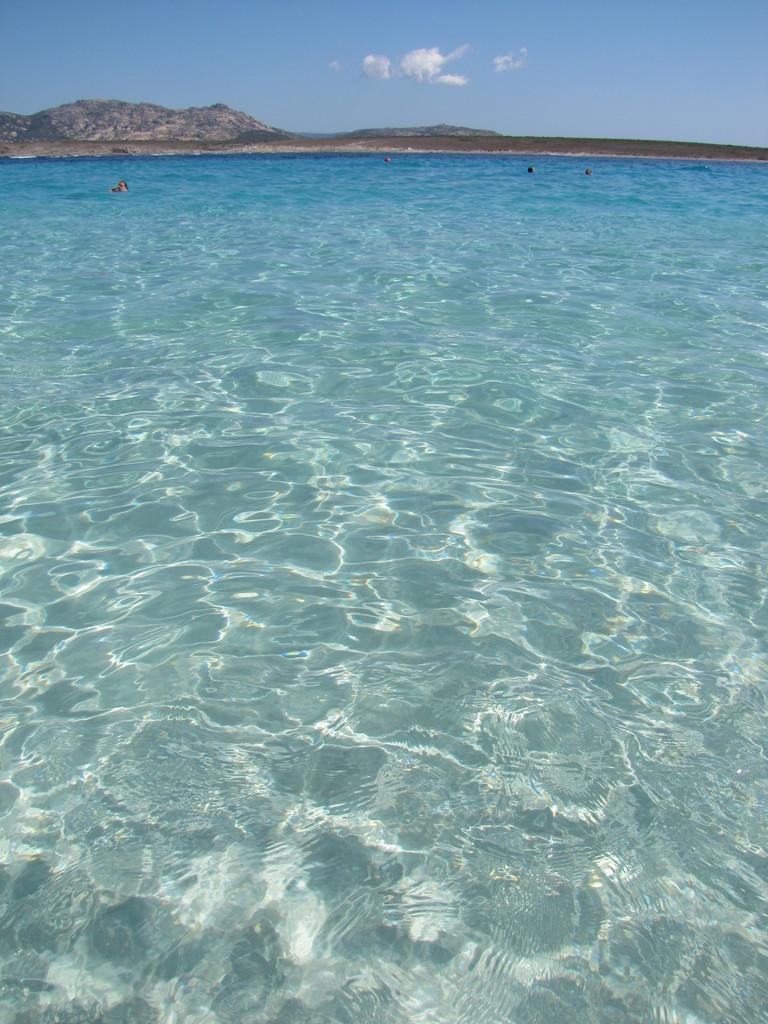In one or two sentences, can you explain what this image depicts? This picture shows water and we see few people swimming and we see a blue cloudy sky. 